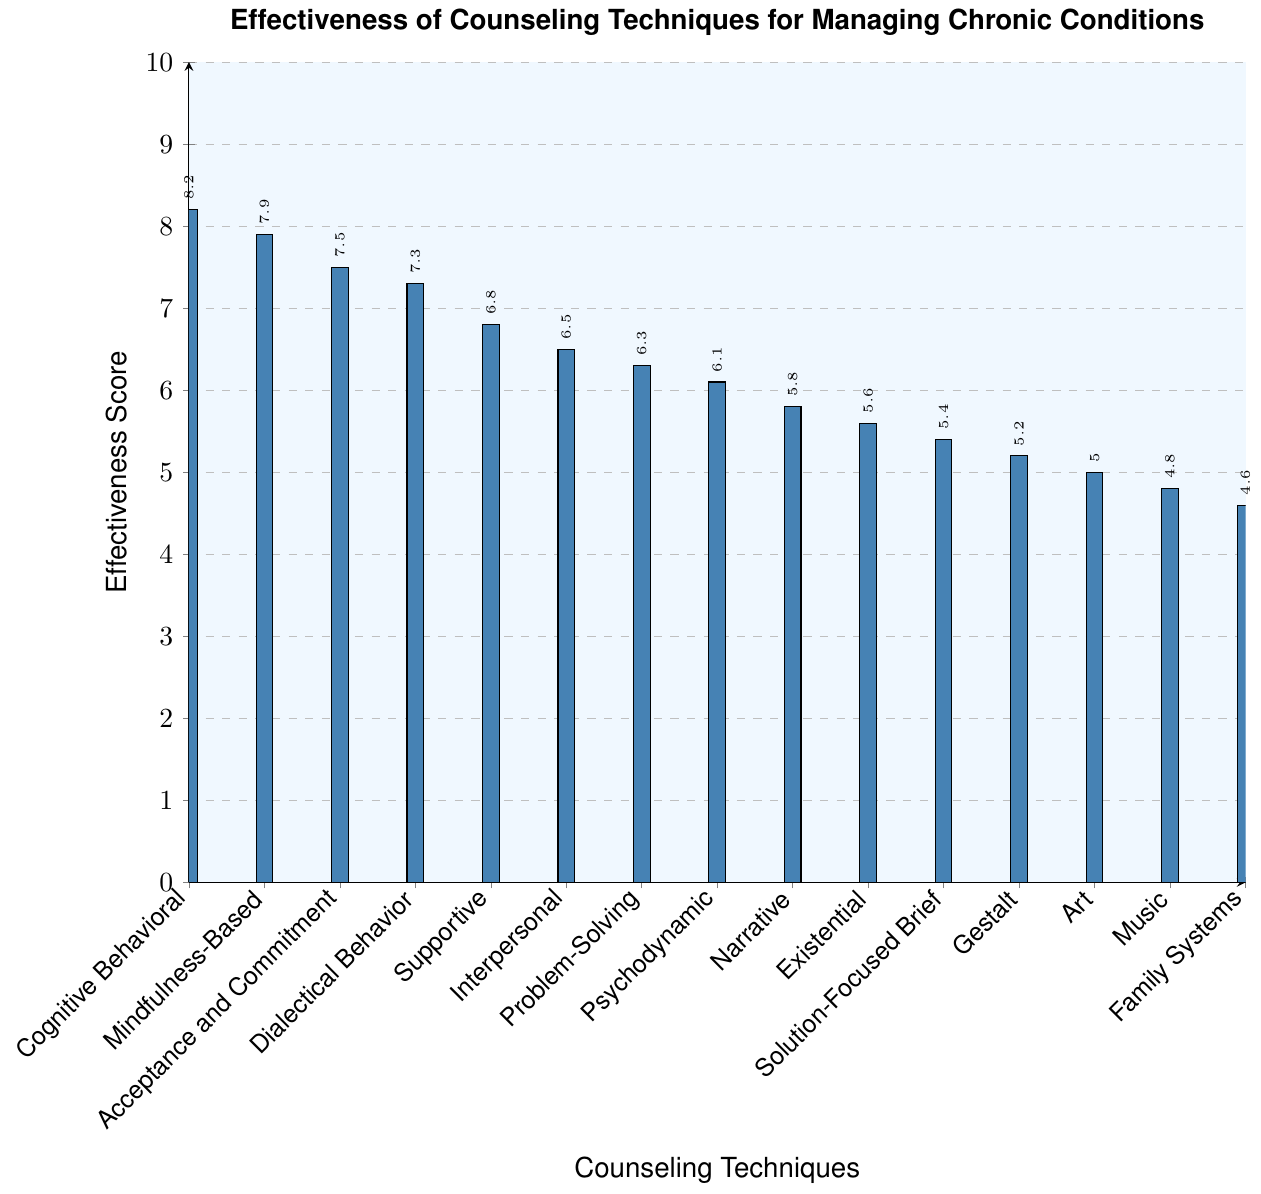Which counseling technique is rated as the most effective? The highest bar corresponds to "Cognitive Behavioral Therapy" with an effectiveness score of 8.2.
Answer: Cognitive Behavioral Therapy What is the effectiveness score of Music Therapy? Locate the bar labeled "Music Therapy"; its height corresponds to an effectiveness score of 4.8.
Answer: 4.8 Which counseling technique has a score just below that of Mindfulness-Based Stress Reduction? "Mindfulness-Based Stress Reduction" has a score of 7.9. The technique with a score just below 7.9 is "Acceptance and Commitment Therapy" with a score of 7.5.
Answer: Acceptance and Commitment Therapy How many counseling techniques have an effectiveness score greater than 7? Look through the y-axis and count the bars that correspond to scores above 7. Those techniques are: "Cognitive Behavioral Therapy", "Mindfulness-Based Stress Reduction", "Acceptance and Commitment Therapy", and "Dialectical Behavior Therapy". There are 4 such techniques.
Answer: 4 What is the difference in effectiveness scores between the highest and the lowest rated techniques? The highest effectiveness score is 8.2 (Cognitive Behavioral Therapy) and the lowest is 4.6 (Family Systems Therapy). The difference is 8.2 - 4.6 = 3.6.
Answer: 3.6 Which technique is slightly less effective than Supportive Psychotherapy? "Supportive Psychotherapy" has a score of 6.8. The technique with a score just slightly less is "Interpersonal Therapy" with a score of 6.5.
Answer: Interpersonal Therapy Which group of therapies has a wider range of scores: those above the middle (6) or those below? Therapies above 6 are: Cognitive Behavioral (8.2), Mindfulness-Based (7.9), Acceptance and Commitment (7.5), Dialectical Behavior (7.3), Supportive (6.8), Interpersonal (6.5), Problem-Solving (6.3), and Psychodynamic (6.1), giving a range of 8.2 - 6.1 = 2.1. Therapies below 6 are: Narrative (5.8), Existential (5.6), Solution-Focused Brief (5.4), Gestalt (5.2), Art (5.0), Music (4.8), Family Systems (4.6), giving a range of 5.8 - 4.6 = 1.2. Therapies above the middle have a wider range.
Answer: Above the middle What is the average effectiveness score of the top three counseling techniques? The top three techniques by effectiveness scores are: "Cognitive Behavioral Therapy (8.2)", "Mindfulness-Based Stress Reduction (7.9)", and "Acceptance and Commitment Therapy (7.5)". The average is calculated as (8.2 + 7.9 + 7.5) / 3 = 7.87.
Answer: 7.87 